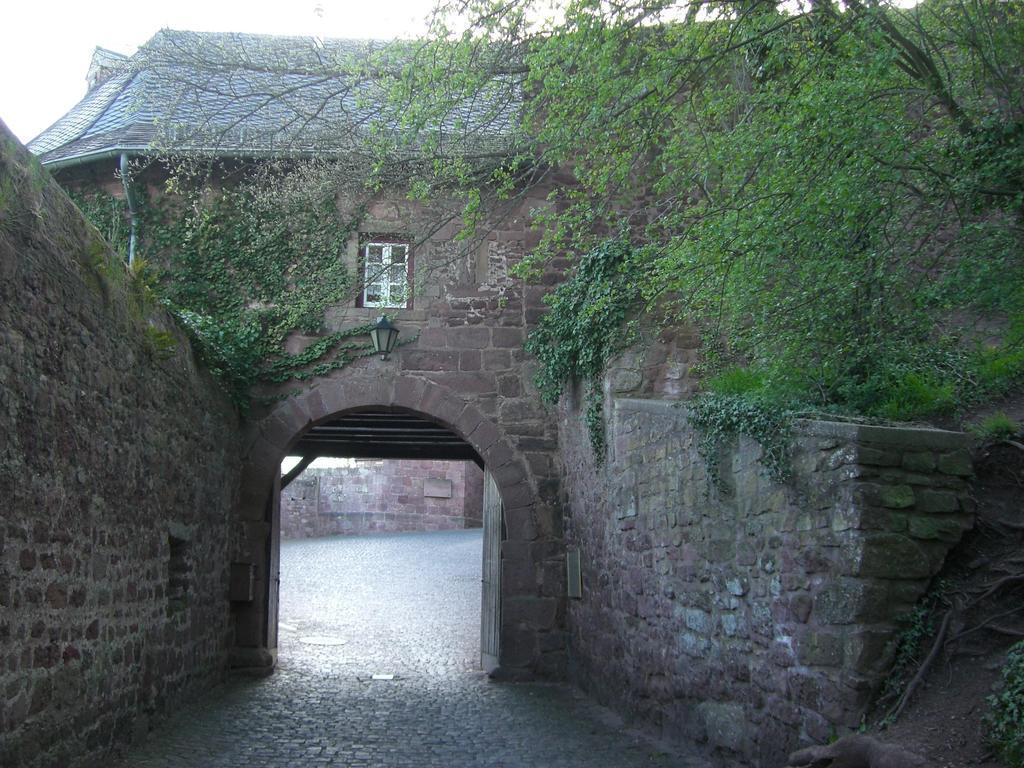In one or two sentences, can you explain what this image depicts? In the middle of the picture, we see an arch and a lantern. On either side of the picture, we see a wall which is made up of stones. On the right side, we see trees. In the background, we see a tree and a house with a grey color roof. This house is made up of stones. 